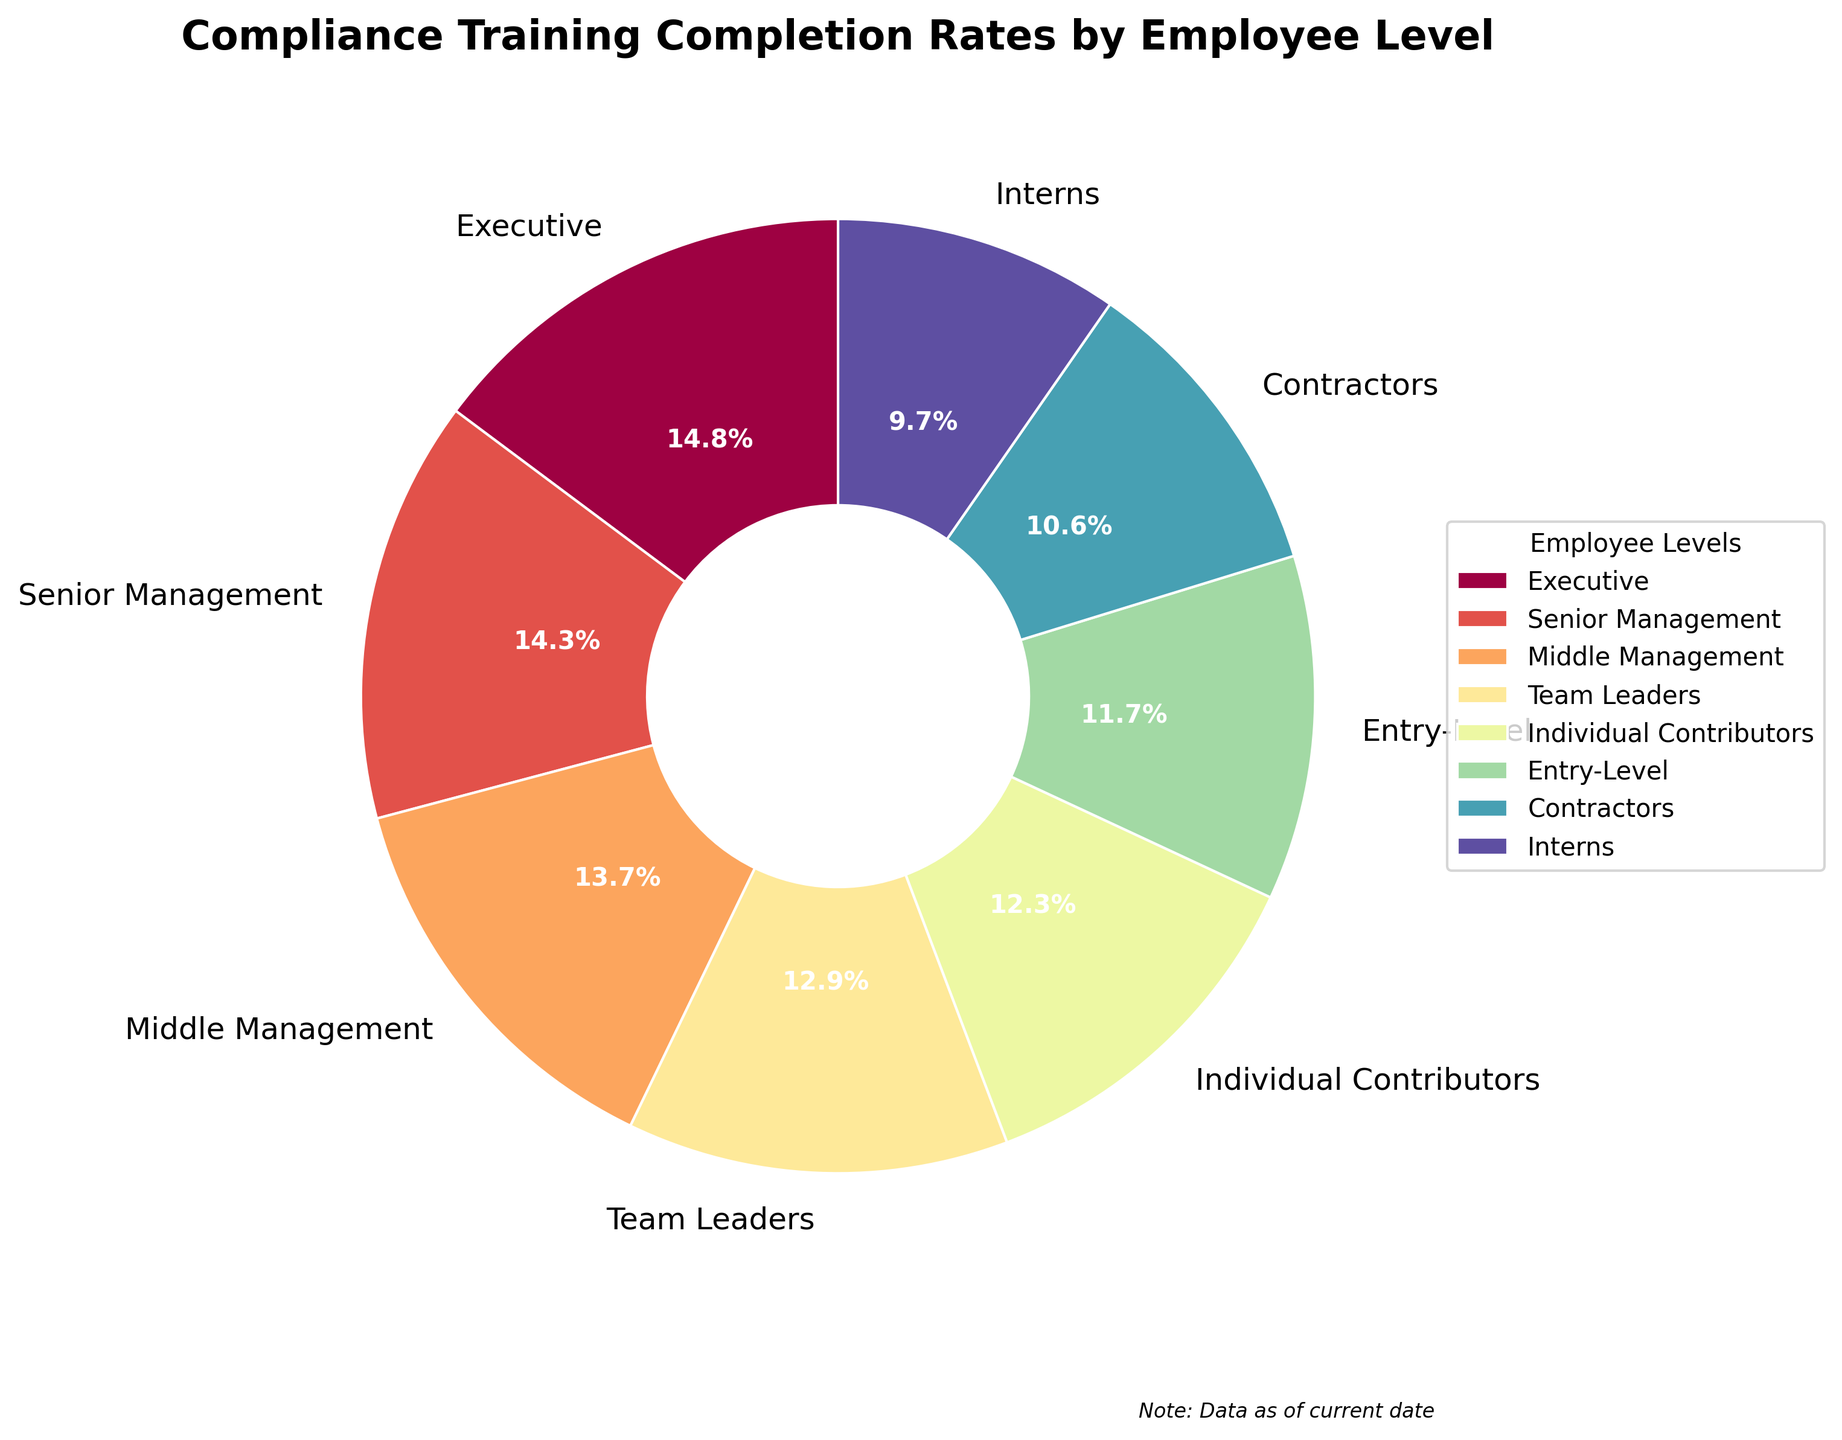What employee level has the highest compliance training completion rate? By looking at the pie chart, we can see that the "Executive" slice has the highest completion rate, which is indicated as 95%.
Answer: Executive Which two employee levels have completion rates below 70%? The pie chart shows that the "Contractors" and "Interns" slices have completion rates below 70%, marked at 68% and 62%, respectively.
Answer: Contractors and Interns What is the difference in completion rates between Team Leaders and Individual Contributors? The completion rate for Team Leaders is 83%, and for Individual Contributors, it is 79%. Subtracting these values gives the difference: 83 - 79 = 4%.
Answer: 4% What is the average compliance training completion rate for all employee levels? Sum all the completion rates of the employee levels and divide by the number of levels: (95 + 92 + 88 + 83 + 79 + 75 + 68 + 62) / 8 = 642 / 8 = 80.25
Answer: 80.25% Which employee level has the second-lowest compliance training completion rate? The pie chart shows that "Interns" have the lowest rate at 62%, and "Contractors" have the second-lowest rate at 68%.
Answer: Contractors Are there more employee levels with completion rates above 80% or below 80%? Counting the slices in the pie chart, those above 80% are Executive, Senior Management, Middle Management, and Team Leaders (4 total). Those below 80% are Individual Contributors, Entry-Level, Contractors, and Interns (4 total). Thus, the counts are equal.
Answer: Equal How much higher is the completion rate of Senior Management compared to Entry-Level employees? From the pie chart, Senior Management has a completion rate of 92%, and Entry-Level employees have 75%. Subtracting these gives: 92 - 75 = 17%.
Answer: 17% Which employee level's completion rate is closest to the average rate? The average rate is 80.25%. By comparing the average to each level's rate, Middle Management (88), Team Leaders (83), and Individual Contributors (79) are closest. Out of these, Individual Contributors (79) are the closest.
Answer: Individual Contributors What proportion of the total does the Interns' completion rate represent? To find this, divide Interns' rate by the total sum of rates and multiply by 100 for the percentage: (62 / 642) * 100 ≈ 9.65%.
Answer: 9.65% By how many percentage points does the completion rate of Middle Management exceed that of Team Leaders? The completion rates are 88% for Middle Management and 83% for Team Leaders. The difference is: 88 - 83 = 5 percentage points.
Answer: 5 